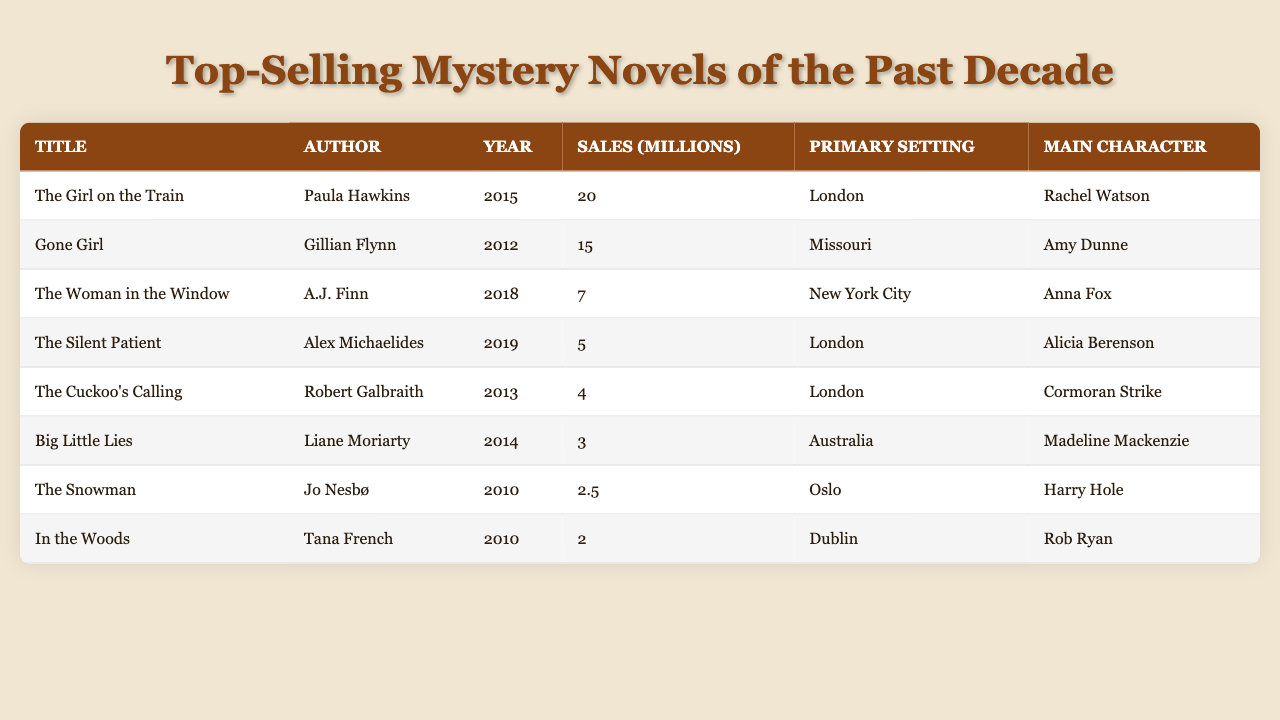What is the title of the top-selling mystery novel? The top-selling mystery novel is the one with the highest sales figure, which is "The Girl on the Train" with 20 million sales.
Answer: The Girl on the Train Who is the author of "Gone Girl"? The author listed for "Gone Girl" in the table is Gillian Flynn.
Answer: Gillian Flynn In which year was "The Woman in the Window" published? The table indicates that "The Woman in the Window" was published in 2018.
Answer: 2018 What is the primary setting of "Big Little Lies"? According to the table, the primary setting for "Big Little Lies" is Australia.
Answer: Australia How many sales did "The Silent Patient" achieve? The table shows that "The Silent Patient" achieved 5 million sales.
Answer: 5 million Which novel has the least sales, and how many were there? Upon review, "In the Woods" has the least sales at 2 million, as indicated in the sales column.
Answer: In the Woods; 2 million Which character is featured in "The Cuckoo's Calling"? The character associated with "The Cuckoo's Calling" is Cormoran Strike, as stated in the main character column.
Answer: Cormoran Strike What is the total sales figure for novels set in London? The novels set in London are "The Girl on the Train," "The Silent Patient," and "The Cuckoo's Calling," with respective sales of 20 million, 5 million, and 4 million. Thus, total sales are 20 + 5 + 4 = 29 million.
Answer: 29 million Is it true that "The Snowman" has sales higher than "In the Woods"? Comparing the sales figures, "The Snowman" has 2.5 million sales while "In the Woods" has 2 million, which confirms that "The Snowman" does have higher sales.
Answer: Yes What is the average sales amount for the novels in the table? The total sales from the table are 20 + 15 + 7 + 5 + 4 + 3 + 2.5 + 2 = 59.5 million from 8 novels. Thus, the average sales are 59.5 / 8 = 7.4375 million.
Answer: 7.44 million Which author had two novels in the table, and what are their titles? There is no author with multiple novels listed in the table, each entry has a unique author. Therefore, the conclusion is that no author had two titles in this list.
Answer: No author with two titles 